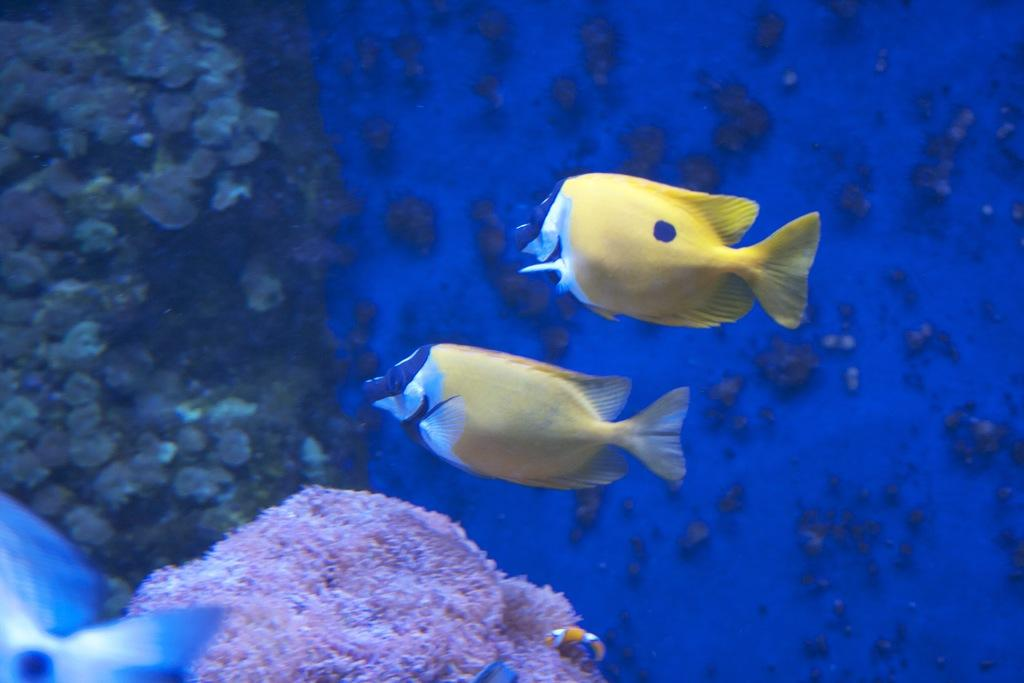What type of environment is depicted in the image? The image depicts a scene underwater. What objects can be seen in the underwater environment? There are water stones visible in the image. How many fish are present in the image? There are two fish in the image. What colors are the fish? The fish are yellow in color, and some parts of them are white. What type of vegetable is growing near the fish in the image? There are no vegetables present in the image; it depicts an underwater scene with fish and water stones. 